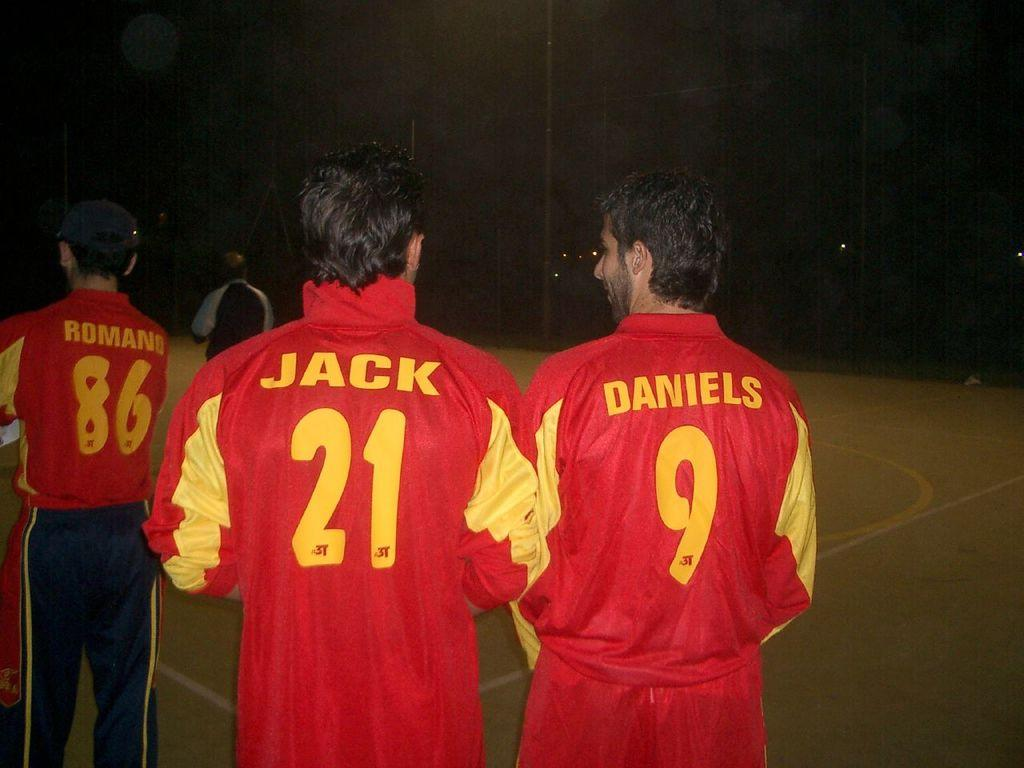<image>
Give a short and clear explanation of the subsequent image. Two men are wearing red jackets, one with the name Jack and the other with the name Daniels. 